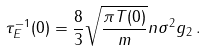<formula> <loc_0><loc_0><loc_500><loc_500>\tau _ { E } ^ { - 1 } ( 0 ) = \frac { 8 } { 3 } \sqrt { \frac { \pi T ( 0 ) } { m } } n \sigma ^ { 2 } g _ { 2 } \, .</formula> 